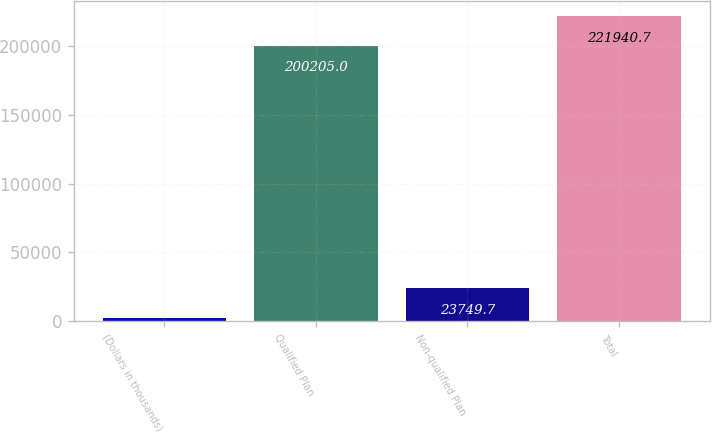<chart> <loc_0><loc_0><loc_500><loc_500><bar_chart><fcel>(Dollars in thousands)<fcel>Qualified Plan<fcel>Non-qualified Plan<fcel>Total<nl><fcel>2014<fcel>200205<fcel>23749.7<fcel>221941<nl></chart> 